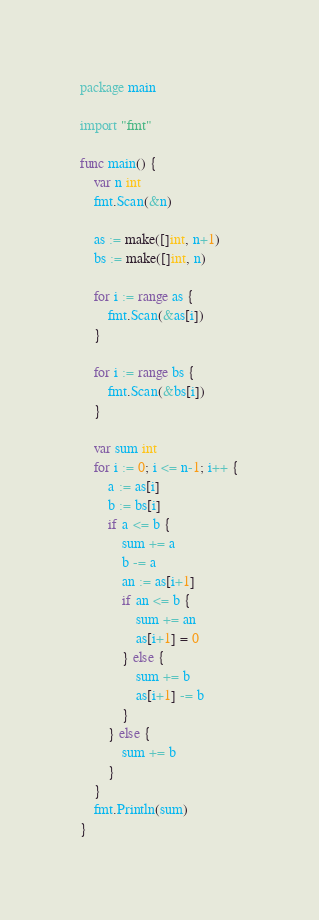Convert code to text. <code><loc_0><loc_0><loc_500><loc_500><_Go_>package main

import "fmt"

func main() {
	var n int
	fmt.Scan(&n)

	as := make([]int, n+1)
	bs := make([]int, n)

	for i := range as {
		fmt.Scan(&as[i])
	}

	for i := range bs {
		fmt.Scan(&bs[i])
	}

	var sum int
	for i := 0; i <= n-1; i++ {
		a := as[i]
		b := bs[i]
		if a <= b {
			sum += a
			b -= a
			an := as[i+1]
			if an <= b {
				sum += an
				as[i+1] = 0
			} else {
				sum += b
				as[i+1] -= b
			}
		} else {
			sum += b
		}
	}
	fmt.Println(sum)
}
</code> 